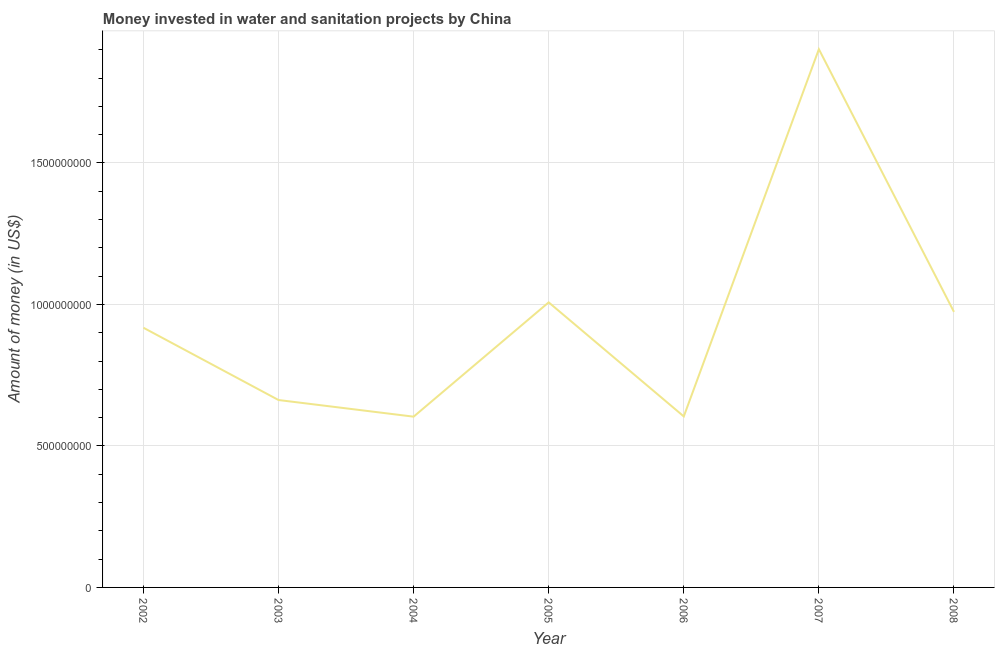What is the investment in 2005?
Give a very brief answer. 1.01e+09. Across all years, what is the maximum investment?
Provide a short and direct response. 1.90e+09. Across all years, what is the minimum investment?
Your response must be concise. 6.03e+08. What is the sum of the investment?
Your answer should be very brief. 6.67e+09. What is the difference between the investment in 2003 and 2005?
Keep it short and to the point. -3.45e+08. What is the average investment per year?
Your answer should be very brief. 9.53e+08. What is the median investment?
Your answer should be compact. 9.18e+08. In how many years, is the investment greater than 1700000000 US$?
Offer a terse response. 1. Do a majority of the years between 2002 and 2007 (inclusive) have investment greater than 1600000000 US$?
Provide a succinct answer. No. What is the ratio of the investment in 2005 to that in 2008?
Give a very brief answer. 1.03. What is the difference between the highest and the second highest investment?
Provide a short and direct response. 8.95e+08. What is the difference between the highest and the lowest investment?
Make the answer very short. 1.30e+09. Does the investment monotonically increase over the years?
Offer a very short reply. No. How many lines are there?
Your answer should be compact. 1. What is the difference between two consecutive major ticks on the Y-axis?
Your answer should be compact. 5.00e+08. Are the values on the major ticks of Y-axis written in scientific E-notation?
Your response must be concise. No. What is the title of the graph?
Your response must be concise. Money invested in water and sanitation projects by China. What is the label or title of the X-axis?
Provide a short and direct response. Year. What is the label or title of the Y-axis?
Your answer should be compact. Amount of money (in US$). What is the Amount of money (in US$) of 2002?
Provide a short and direct response. 9.18e+08. What is the Amount of money (in US$) in 2003?
Your answer should be compact. 6.62e+08. What is the Amount of money (in US$) of 2004?
Your response must be concise. 6.03e+08. What is the Amount of money (in US$) in 2005?
Give a very brief answer. 1.01e+09. What is the Amount of money (in US$) of 2006?
Provide a succinct answer. 6.04e+08. What is the Amount of money (in US$) of 2007?
Your answer should be compact. 1.90e+09. What is the Amount of money (in US$) in 2008?
Your response must be concise. 9.74e+08. What is the difference between the Amount of money (in US$) in 2002 and 2003?
Make the answer very short. 2.55e+08. What is the difference between the Amount of money (in US$) in 2002 and 2004?
Give a very brief answer. 3.14e+08. What is the difference between the Amount of money (in US$) in 2002 and 2005?
Keep it short and to the point. -8.97e+07. What is the difference between the Amount of money (in US$) in 2002 and 2006?
Provide a succinct answer. 3.13e+08. What is the difference between the Amount of money (in US$) in 2002 and 2007?
Ensure brevity in your answer.  -9.84e+08. What is the difference between the Amount of money (in US$) in 2002 and 2008?
Make the answer very short. -5.60e+07. What is the difference between the Amount of money (in US$) in 2003 and 2004?
Provide a succinct answer. 5.88e+07. What is the difference between the Amount of money (in US$) in 2003 and 2005?
Provide a succinct answer. -3.45e+08. What is the difference between the Amount of money (in US$) in 2003 and 2006?
Your response must be concise. 5.79e+07. What is the difference between the Amount of money (in US$) in 2003 and 2007?
Keep it short and to the point. -1.24e+09. What is the difference between the Amount of money (in US$) in 2003 and 2008?
Make the answer very short. -3.11e+08. What is the difference between the Amount of money (in US$) in 2004 and 2005?
Provide a short and direct response. -4.04e+08. What is the difference between the Amount of money (in US$) in 2004 and 2006?
Provide a short and direct response. -8.81e+05. What is the difference between the Amount of money (in US$) in 2004 and 2007?
Give a very brief answer. -1.30e+09. What is the difference between the Amount of money (in US$) in 2004 and 2008?
Provide a succinct answer. -3.70e+08. What is the difference between the Amount of money (in US$) in 2005 and 2006?
Provide a succinct answer. 4.03e+08. What is the difference between the Amount of money (in US$) in 2005 and 2007?
Offer a very short reply. -8.95e+08. What is the difference between the Amount of money (in US$) in 2005 and 2008?
Give a very brief answer. 3.37e+07. What is the difference between the Amount of money (in US$) in 2006 and 2007?
Provide a succinct answer. -1.30e+09. What is the difference between the Amount of money (in US$) in 2006 and 2008?
Ensure brevity in your answer.  -3.69e+08. What is the difference between the Amount of money (in US$) in 2007 and 2008?
Your response must be concise. 9.28e+08. What is the ratio of the Amount of money (in US$) in 2002 to that in 2003?
Offer a very short reply. 1.39. What is the ratio of the Amount of money (in US$) in 2002 to that in 2004?
Your answer should be very brief. 1.52. What is the ratio of the Amount of money (in US$) in 2002 to that in 2005?
Provide a succinct answer. 0.91. What is the ratio of the Amount of money (in US$) in 2002 to that in 2006?
Ensure brevity in your answer.  1.52. What is the ratio of the Amount of money (in US$) in 2002 to that in 2007?
Offer a terse response. 0.48. What is the ratio of the Amount of money (in US$) in 2002 to that in 2008?
Ensure brevity in your answer.  0.94. What is the ratio of the Amount of money (in US$) in 2003 to that in 2004?
Make the answer very short. 1.1. What is the ratio of the Amount of money (in US$) in 2003 to that in 2005?
Make the answer very short. 0.66. What is the ratio of the Amount of money (in US$) in 2003 to that in 2006?
Give a very brief answer. 1.1. What is the ratio of the Amount of money (in US$) in 2003 to that in 2007?
Provide a short and direct response. 0.35. What is the ratio of the Amount of money (in US$) in 2003 to that in 2008?
Provide a succinct answer. 0.68. What is the ratio of the Amount of money (in US$) in 2004 to that in 2005?
Provide a succinct answer. 0.6. What is the ratio of the Amount of money (in US$) in 2004 to that in 2007?
Your answer should be very brief. 0.32. What is the ratio of the Amount of money (in US$) in 2004 to that in 2008?
Your answer should be compact. 0.62. What is the ratio of the Amount of money (in US$) in 2005 to that in 2006?
Provide a short and direct response. 1.67. What is the ratio of the Amount of money (in US$) in 2005 to that in 2007?
Your answer should be very brief. 0.53. What is the ratio of the Amount of money (in US$) in 2005 to that in 2008?
Make the answer very short. 1.03. What is the ratio of the Amount of money (in US$) in 2006 to that in 2007?
Provide a succinct answer. 0.32. What is the ratio of the Amount of money (in US$) in 2006 to that in 2008?
Your answer should be very brief. 0.62. What is the ratio of the Amount of money (in US$) in 2007 to that in 2008?
Make the answer very short. 1.95. 